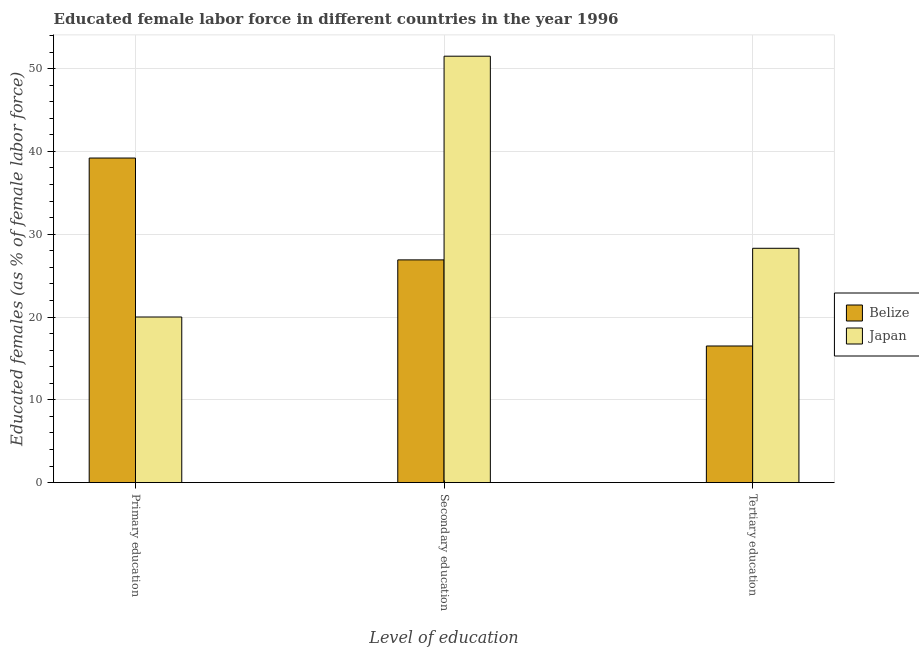How many bars are there on the 3rd tick from the left?
Make the answer very short. 2. What is the label of the 3rd group of bars from the left?
Offer a very short reply. Tertiary education. What is the percentage of female labor force who received tertiary education in Japan?
Your answer should be very brief. 28.3. Across all countries, what is the maximum percentage of female labor force who received secondary education?
Ensure brevity in your answer.  51.5. In which country was the percentage of female labor force who received secondary education maximum?
Keep it short and to the point. Japan. In which country was the percentage of female labor force who received primary education minimum?
Keep it short and to the point. Japan. What is the total percentage of female labor force who received primary education in the graph?
Your answer should be compact. 59.2. What is the difference between the percentage of female labor force who received tertiary education in Belize and that in Japan?
Keep it short and to the point. -11.8. What is the difference between the percentage of female labor force who received tertiary education in Japan and the percentage of female labor force who received primary education in Belize?
Provide a succinct answer. -10.9. What is the average percentage of female labor force who received secondary education per country?
Offer a very short reply. 39.2. What is the difference between the percentage of female labor force who received primary education and percentage of female labor force who received secondary education in Belize?
Provide a succinct answer. 12.3. In how many countries, is the percentage of female labor force who received primary education greater than 46 %?
Your answer should be compact. 0. What is the ratio of the percentage of female labor force who received tertiary education in Japan to that in Belize?
Offer a terse response. 1.72. What is the difference between the highest and the second highest percentage of female labor force who received secondary education?
Ensure brevity in your answer.  24.6. What is the difference between the highest and the lowest percentage of female labor force who received primary education?
Keep it short and to the point. 19.2. Is it the case that in every country, the sum of the percentage of female labor force who received primary education and percentage of female labor force who received secondary education is greater than the percentage of female labor force who received tertiary education?
Your answer should be very brief. Yes. How many bars are there?
Your response must be concise. 6. What is the difference between two consecutive major ticks on the Y-axis?
Offer a very short reply. 10. Are the values on the major ticks of Y-axis written in scientific E-notation?
Your response must be concise. No. Where does the legend appear in the graph?
Your answer should be compact. Center right. How many legend labels are there?
Provide a short and direct response. 2. What is the title of the graph?
Keep it short and to the point. Educated female labor force in different countries in the year 1996. Does "Lebanon" appear as one of the legend labels in the graph?
Your answer should be compact. No. What is the label or title of the X-axis?
Offer a terse response. Level of education. What is the label or title of the Y-axis?
Give a very brief answer. Educated females (as % of female labor force). What is the Educated females (as % of female labor force) of Belize in Primary education?
Provide a succinct answer. 39.2. What is the Educated females (as % of female labor force) in Japan in Primary education?
Give a very brief answer. 20. What is the Educated females (as % of female labor force) in Belize in Secondary education?
Ensure brevity in your answer.  26.9. What is the Educated females (as % of female labor force) of Japan in Secondary education?
Your answer should be very brief. 51.5. What is the Educated females (as % of female labor force) in Japan in Tertiary education?
Provide a short and direct response. 28.3. Across all Level of education, what is the maximum Educated females (as % of female labor force) in Belize?
Ensure brevity in your answer.  39.2. Across all Level of education, what is the maximum Educated females (as % of female labor force) in Japan?
Your response must be concise. 51.5. What is the total Educated females (as % of female labor force) in Belize in the graph?
Offer a very short reply. 82.6. What is the total Educated females (as % of female labor force) of Japan in the graph?
Offer a very short reply. 99.8. What is the difference between the Educated females (as % of female labor force) in Belize in Primary education and that in Secondary education?
Make the answer very short. 12.3. What is the difference between the Educated females (as % of female labor force) of Japan in Primary education and that in Secondary education?
Ensure brevity in your answer.  -31.5. What is the difference between the Educated females (as % of female labor force) in Belize in Primary education and that in Tertiary education?
Make the answer very short. 22.7. What is the difference between the Educated females (as % of female labor force) of Japan in Primary education and that in Tertiary education?
Make the answer very short. -8.3. What is the difference between the Educated females (as % of female labor force) in Japan in Secondary education and that in Tertiary education?
Your response must be concise. 23.2. What is the difference between the Educated females (as % of female labor force) in Belize in Secondary education and the Educated females (as % of female labor force) in Japan in Tertiary education?
Your answer should be very brief. -1.4. What is the average Educated females (as % of female labor force) of Belize per Level of education?
Your answer should be very brief. 27.53. What is the average Educated females (as % of female labor force) in Japan per Level of education?
Your answer should be very brief. 33.27. What is the difference between the Educated females (as % of female labor force) of Belize and Educated females (as % of female labor force) of Japan in Secondary education?
Offer a terse response. -24.6. What is the difference between the Educated females (as % of female labor force) in Belize and Educated females (as % of female labor force) in Japan in Tertiary education?
Keep it short and to the point. -11.8. What is the ratio of the Educated females (as % of female labor force) in Belize in Primary education to that in Secondary education?
Your response must be concise. 1.46. What is the ratio of the Educated females (as % of female labor force) in Japan in Primary education to that in Secondary education?
Your answer should be compact. 0.39. What is the ratio of the Educated females (as % of female labor force) in Belize in Primary education to that in Tertiary education?
Your response must be concise. 2.38. What is the ratio of the Educated females (as % of female labor force) in Japan in Primary education to that in Tertiary education?
Provide a succinct answer. 0.71. What is the ratio of the Educated females (as % of female labor force) of Belize in Secondary education to that in Tertiary education?
Offer a terse response. 1.63. What is the ratio of the Educated females (as % of female labor force) of Japan in Secondary education to that in Tertiary education?
Offer a very short reply. 1.82. What is the difference between the highest and the second highest Educated females (as % of female labor force) of Belize?
Provide a short and direct response. 12.3. What is the difference between the highest and the second highest Educated females (as % of female labor force) in Japan?
Provide a short and direct response. 23.2. What is the difference between the highest and the lowest Educated females (as % of female labor force) of Belize?
Keep it short and to the point. 22.7. What is the difference between the highest and the lowest Educated females (as % of female labor force) in Japan?
Keep it short and to the point. 31.5. 